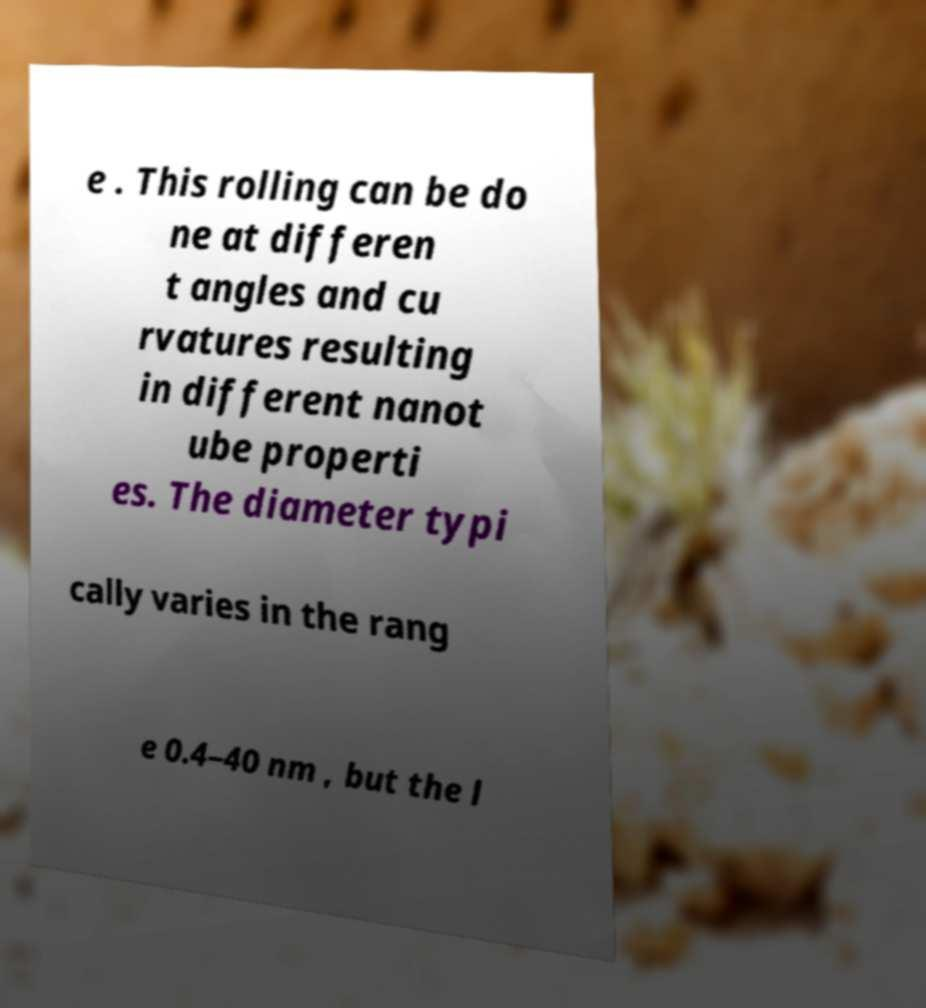Can you read and provide the text displayed in the image?This photo seems to have some interesting text. Can you extract and type it out for me? e . This rolling can be do ne at differen t angles and cu rvatures resulting in different nanot ube properti es. The diameter typi cally varies in the rang e 0.4–40 nm , but the l 